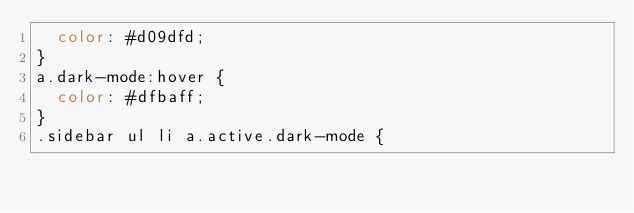Convert code to text. <code><loc_0><loc_0><loc_500><loc_500><_CSS_>  color: #d09dfd;
}
a.dark-mode:hover {
  color: #dfbaff;
}
.sidebar ul li a.active.dark-mode {</code> 